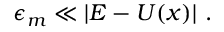Convert formula to latex. <formula><loc_0><loc_0><loc_500><loc_500>\epsilon _ { m } \ll | E - U ( x ) | \ .</formula> 